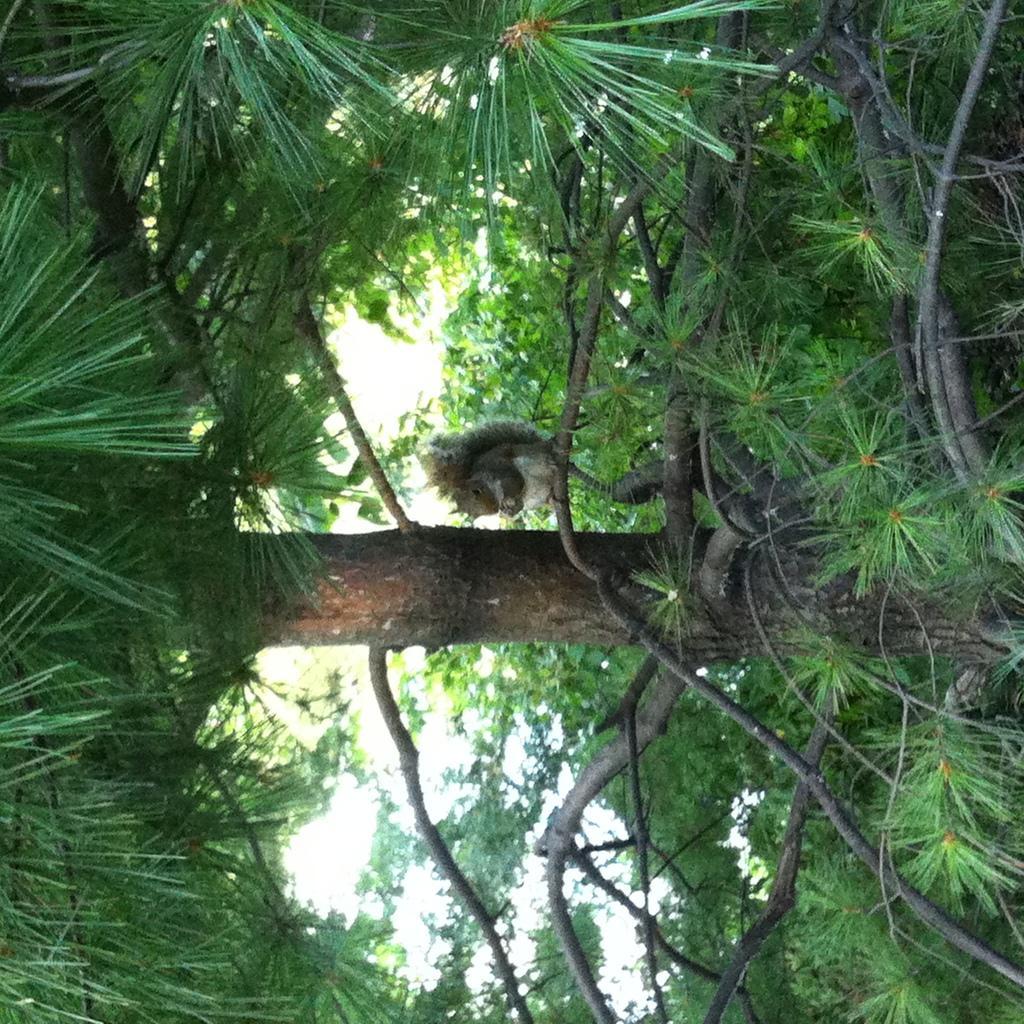Can you describe this image briefly? In this picture I can observe some trees and plants on the ground. In the background there is sky. There is a squirrel on the branch of the tree in the middle of the picture. 